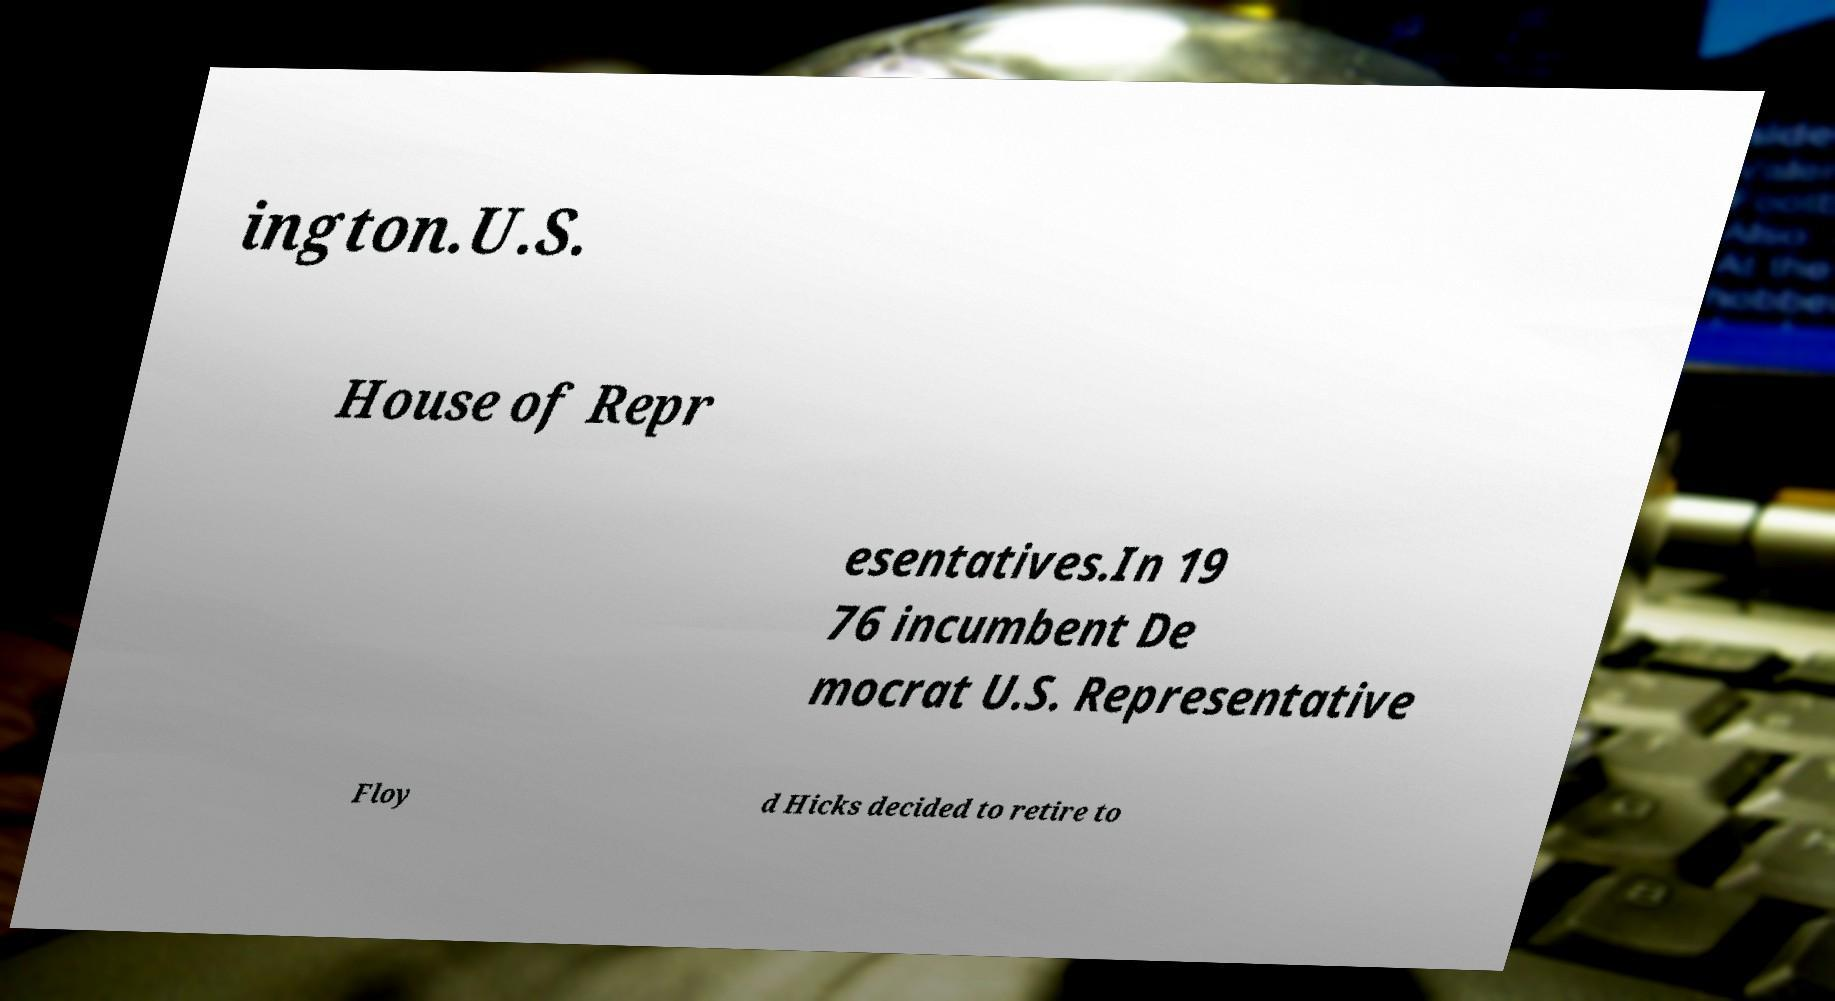Please identify and transcribe the text found in this image. ington.U.S. House of Repr esentatives.In 19 76 incumbent De mocrat U.S. Representative Floy d Hicks decided to retire to 